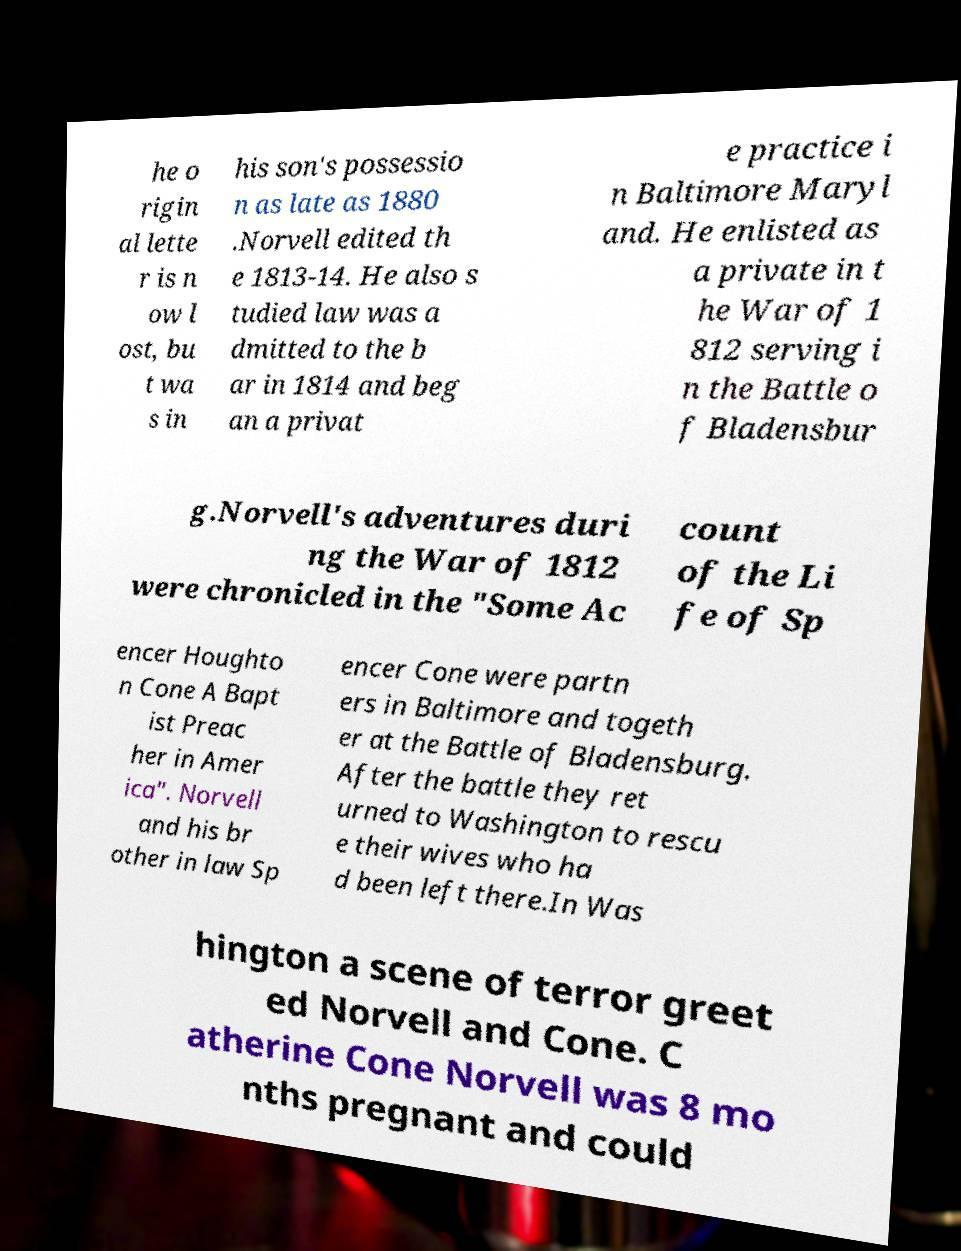Could you extract and type out the text from this image? he o rigin al lette r is n ow l ost, bu t wa s in his son's possessio n as late as 1880 .Norvell edited th e 1813-14. He also s tudied law was a dmitted to the b ar in 1814 and beg an a privat e practice i n Baltimore Maryl and. He enlisted as a private in t he War of 1 812 serving i n the Battle o f Bladensbur g.Norvell's adventures duri ng the War of 1812 were chronicled in the "Some Ac count of the Li fe of Sp encer Houghto n Cone A Bapt ist Preac her in Amer ica". Norvell and his br other in law Sp encer Cone were partn ers in Baltimore and togeth er at the Battle of Bladensburg. After the battle they ret urned to Washington to rescu e their wives who ha d been left there.In Was hington a scene of terror greet ed Norvell and Cone. C atherine Cone Norvell was 8 mo nths pregnant and could 